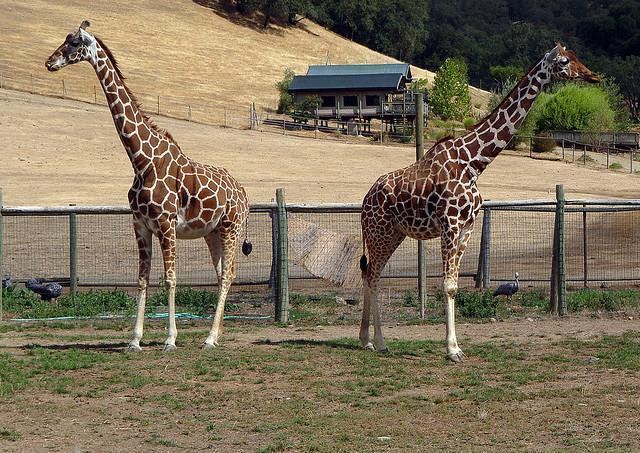How many animals are there?
Give a very brief answer. 2. How many giraffes are there?
Give a very brief answer. 2. How many giraffes can be seen?
Give a very brief answer. 2. 